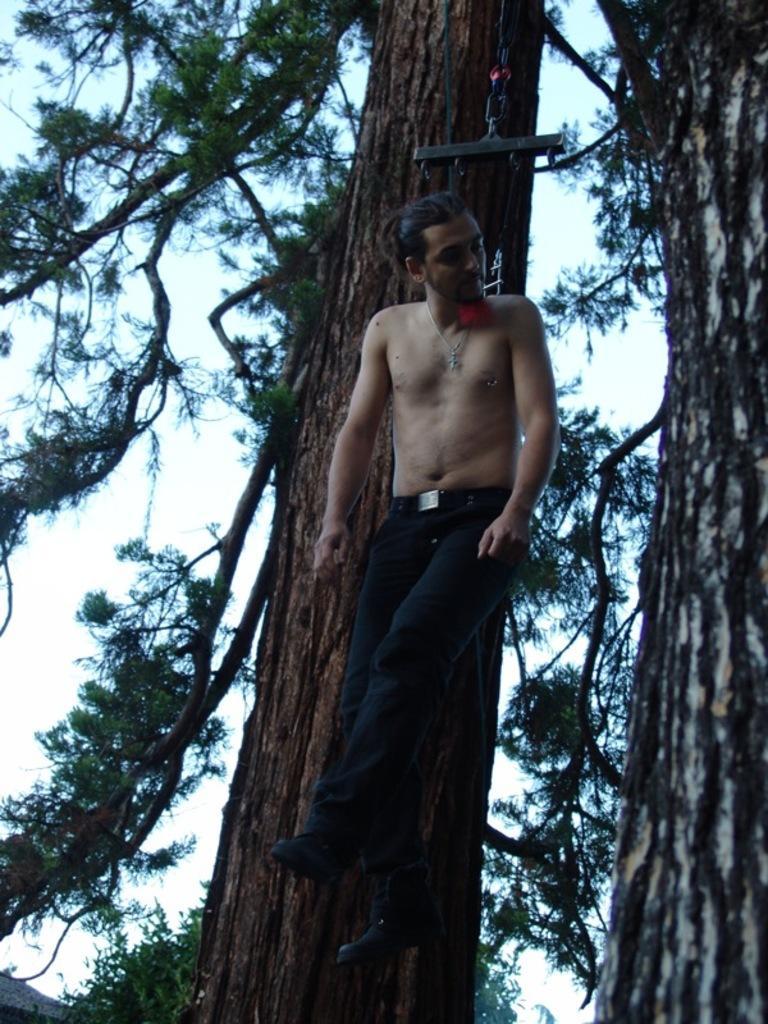How would you summarize this image in a sentence or two? In the middle of this image I can see a man hanging on a rope and there are two trees. In the background, I can see the sky. 